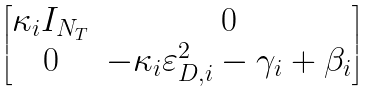Convert formula to latex. <formula><loc_0><loc_0><loc_500><loc_500>\begin{bmatrix} \kappa _ { i } I _ { N _ { T } } & 0 \\ 0 & - \kappa _ { i } \varepsilon _ { D , i } ^ { 2 } - \gamma _ { i } + \beta _ { i } \end{bmatrix}</formula> 